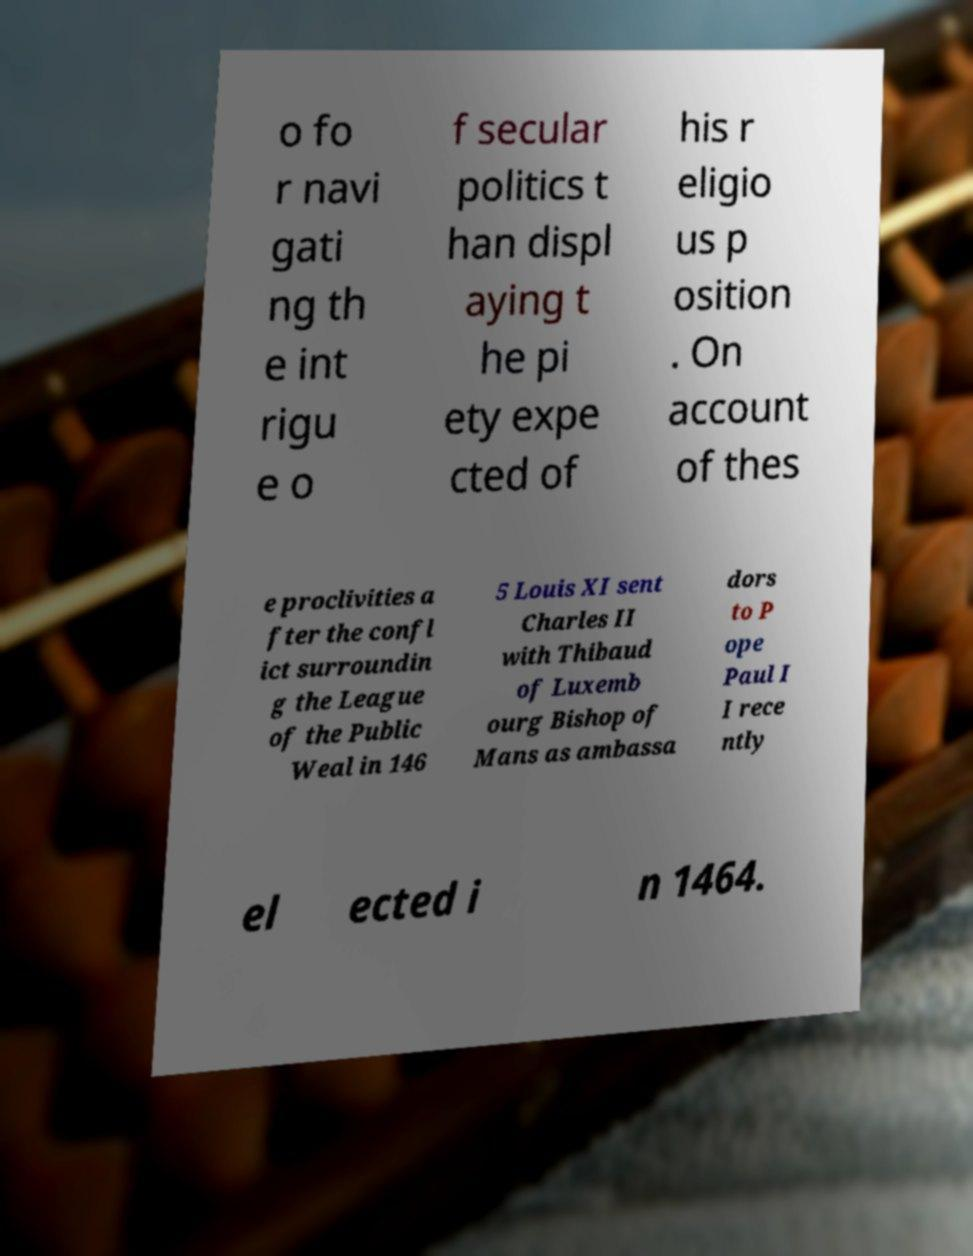Could you assist in decoding the text presented in this image and type it out clearly? o fo r navi gati ng th e int rigu e o f secular politics t han displ aying t he pi ety expe cted of his r eligio us p osition . On account of thes e proclivities a fter the confl ict surroundin g the League of the Public Weal in 146 5 Louis XI sent Charles II with Thibaud of Luxemb ourg Bishop of Mans as ambassa dors to P ope Paul I I rece ntly el ected i n 1464. 